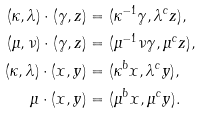Convert formula to latex. <formula><loc_0><loc_0><loc_500><loc_500>( \kappa , \lambda ) \cdot ( \gamma , z ) & = ( \kappa ^ { - 1 } \gamma , \lambda ^ { c } z ) , \\ ( \mu , \nu ) \cdot ( \gamma , z ) & = ( \mu ^ { - 1 } \nu \gamma , \mu ^ { c } z ) , \\ ( \kappa , \lambda ) \cdot ( x , y ) & = ( \kappa ^ { b } x , \lambda ^ { c } y ) , \\ \mu \cdot ( x , y ) & = ( \mu ^ { b } x , \mu ^ { c } y ) .</formula> 